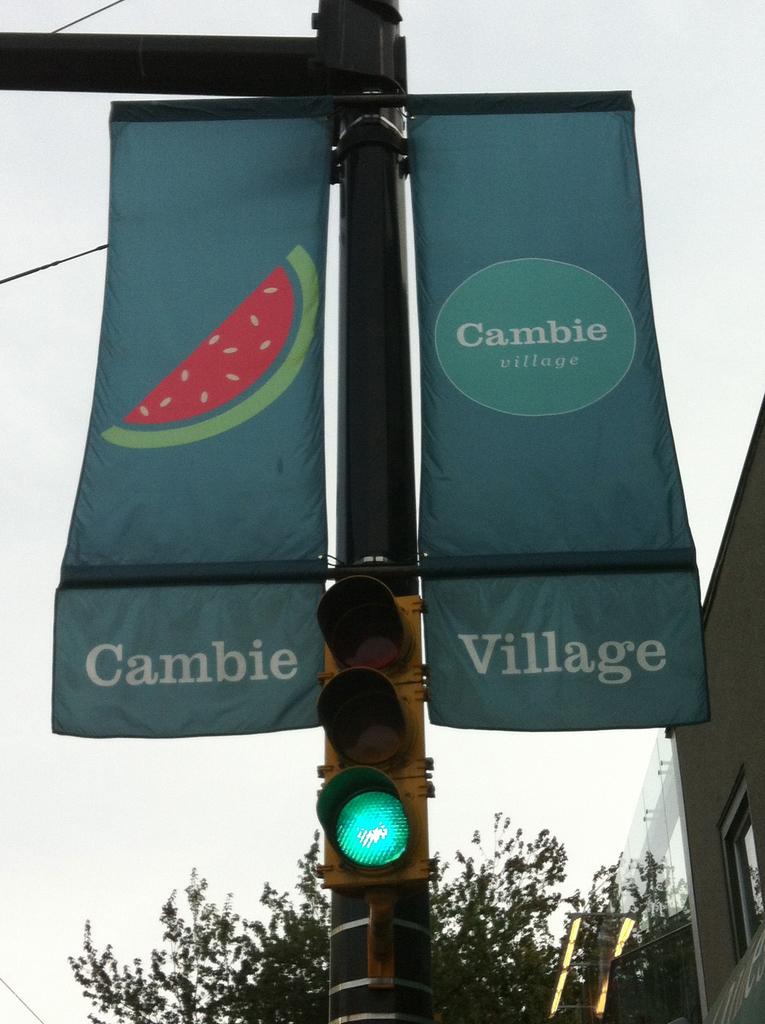What is this banner featuring?
Offer a terse response. Cambie village. What is the word on the right?
Provide a succinct answer. Village. 